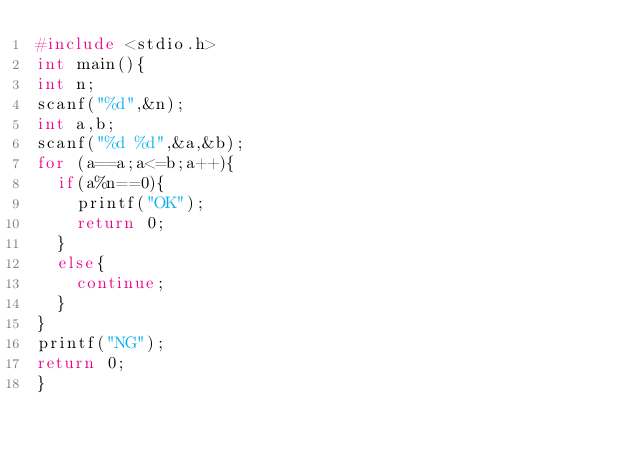<code> <loc_0><loc_0><loc_500><loc_500><_C++_>#include <stdio.h>
int main(){
int n;
scanf("%d",&n);
int a,b;
scanf("%d %d",&a,&b);
for (a==a;a<=b;a++){
	if(a%n==0){
		printf("OK");
		return 0;
	}
	else{
		continue;
	}
}
printf("NG");
return 0;
}
</code> 